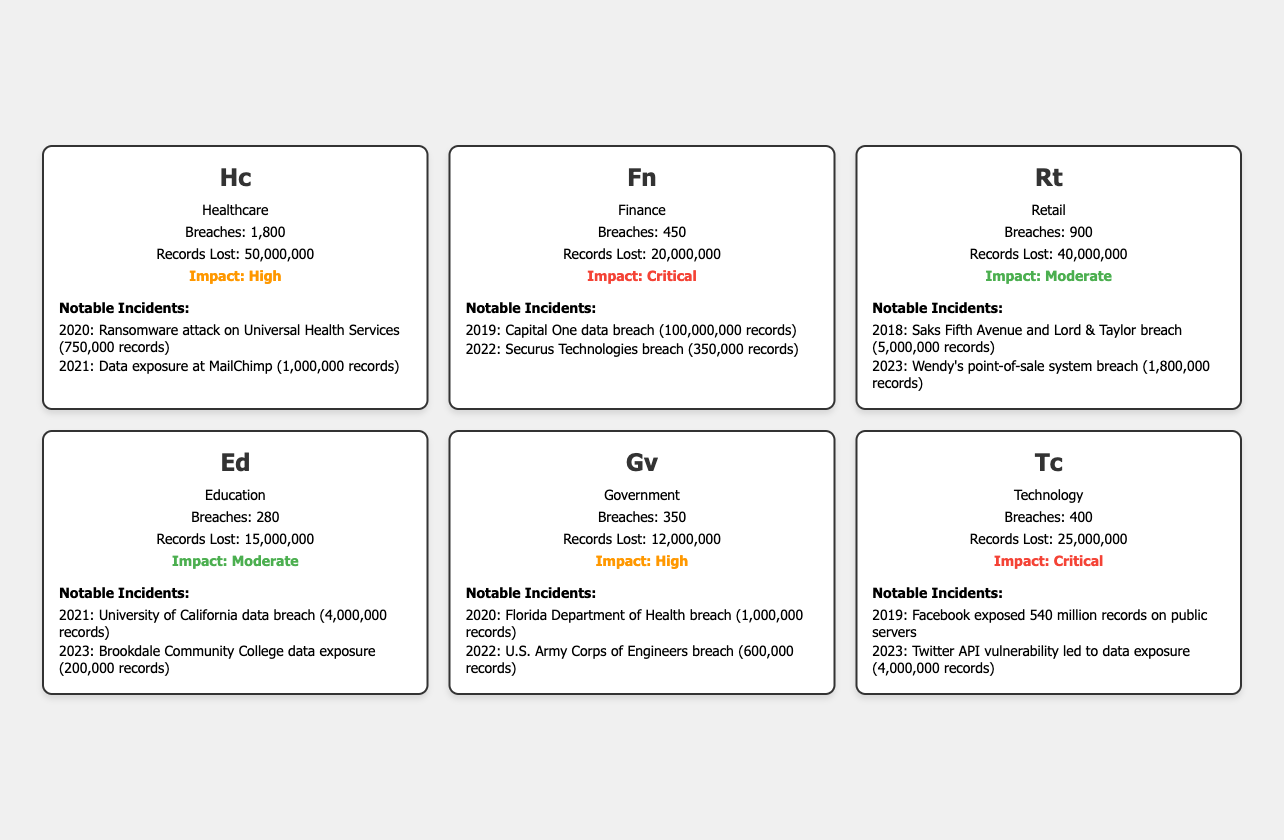What industry has the highest number of data breaches? By checking the breaches column in the table, Healthcare has the highest count with 1,800 breaches.
Answer: Healthcare What was the total number of records lost in the Finance industry? The data shows that 20,000,000 records were lost in the Finance industry, as listed in the records lost column.
Answer: 20,000,000 Is the impact level of the Retail industry considered critical? The impact of the Retail industry is listed as Moderate, which is not classified as Critical.
Answer: No How many notable incidents occurred in the Technology industry from 2018 to 2023? The Technology industry has listed two notable incidents, one in 2019 and another in 2023.
Answer: 2 Which industry experienced the fewest data breaches? By comparing the breaches for all the industries, Education has the fewest breaches, with a total of 280 breaches.
Answer: Education What is the difference in records lost between the Healthcare and Government industries? The Healthcare industry lost 50,000,000 records while the Government lost 12,000,000 records. The difference is 50,000,000 - 12,000,000 = 38,000,000.
Answer: 38,000,000 Which notable incident led to the highest number of records lost within the Finance industry? The Capital One data breach in 2019 is noted as causing the loss of 100,000,000 records, which is the highest in the Finance industry.
Answer: Capital One data breach Overall, which industry has the most critical impact according to the table? The Financial and Technology industries both have a Critical impact level, but Finance has the higher number of total breaches and records lost associated with notable incidents.
Answer: Finance How many total data breaches are listed across all industries? Summing the breaches from all industries: 1,800 (Healthcare) + 450 (Finance) + 900 (Retail) + 280 (Education) + 350 (Government) + 400 (Technology) gives a total of 4,180 breaches.
Answer: 4,180 